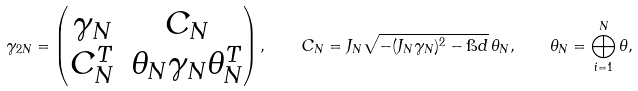Convert formula to latex. <formula><loc_0><loc_0><loc_500><loc_500>\gamma _ { 2 N } = \begin{pmatrix} \gamma _ { N } & C _ { N } \\ C _ { N } ^ { T } & \theta _ { N } \gamma _ { N } \theta _ { N } ^ { T } \end{pmatrix} , \quad C _ { N } = J _ { N } \sqrt { - ( J _ { N } \gamma _ { N } ) ^ { 2 } - \i d } \, \theta _ { N } , \quad \theta _ { N } = \bigoplus _ { i = 1 } ^ { N } \theta ,</formula> 